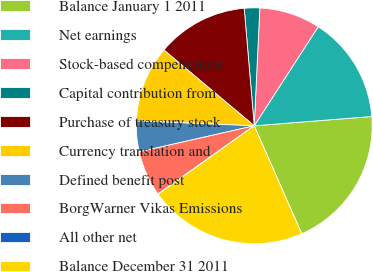<chart> <loc_0><loc_0><loc_500><loc_500><pie_chart><fcel>Balance January 1 2011<fcel>Net earnings<fcel>Stock-based compensation<fcel>Capital contribution from<fcel>Purchase of treasury stock<fcel>Currency translation and<fcel>Defined benefit post<fcel>BorgWarner Vikas Emissions<fcel>All other net<fcel>Balance December 31 2011<nl><fcel>19.66%<fcel>14.62%<fcel>8.37%<fcel>2.11%<fcel>12.54%<fcel>10.45%<fcel>4.2%<fcel>6.28%<fcel>0.03%<fcel>21.74%<nl></chart> 